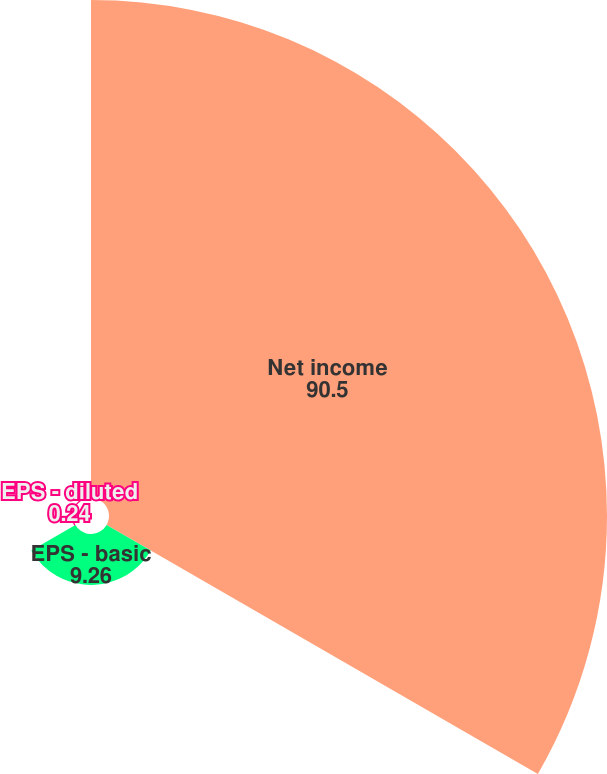Convert chart to OTSL. <chart><loc_0><loc_0><loc_500><loc_500><pie_chart><fcel>Net income<fcel>EPS - basic<fcel>EPS - diluted<nl><fcel>90.5%<fcel>9.26%<fcel>0.24%<nl></chart> 